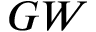<formula> <loc_0><loc_0><loc_500><loc_500>G W</formula> 